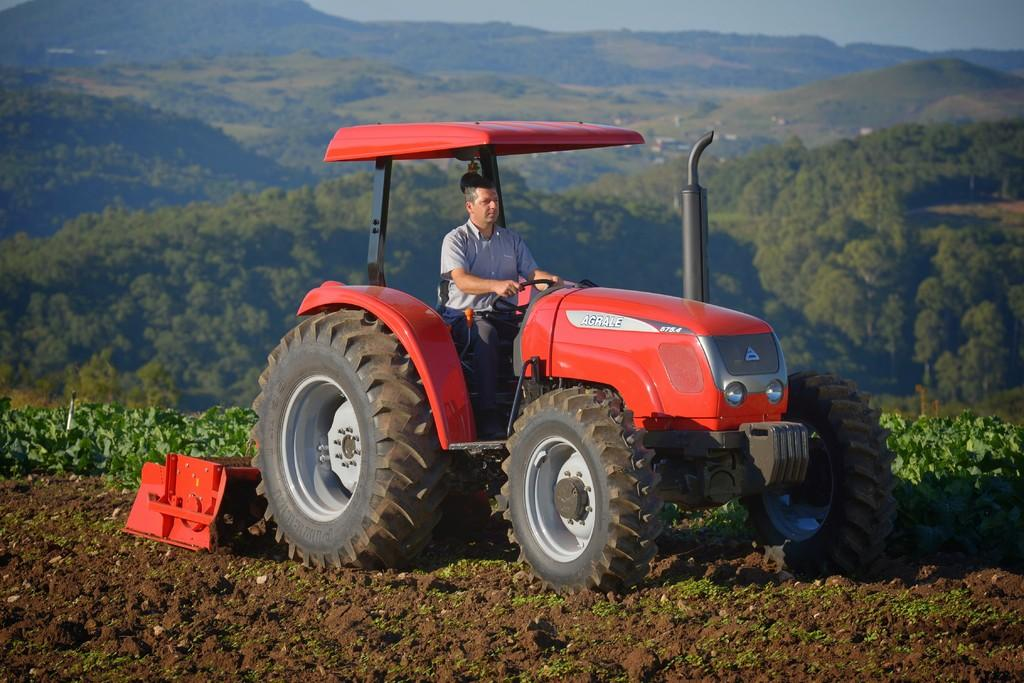Who is present in the image? There is a man in the image. What is the man doing in the image? The man is sitting on a vehicle. What can be seen in the background of the image? There are mountains and trees in the background of the image. What type of paper is the man holding in his hand in the image? There is no paper visible in the man's hand in the image. What thoughts might the man be having while sitting on the vehicle in the image? We cannot determine the man's thoughts from the image alone, as thoughts are not visible. 